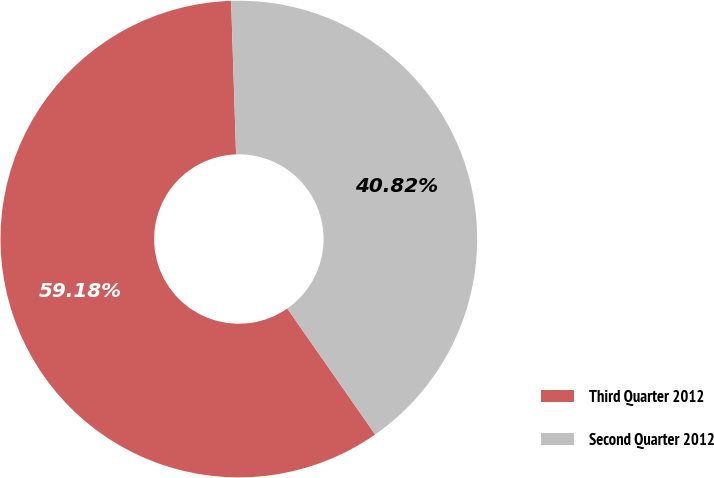<chart> <loc_0><loc_0><loc_500><loc_500><pie_chart><fcel>Third Quarter 2012<fcel>Second Quarter 2012<nl><fcel>59.18%<fcel>40.82%<nl></chart> 